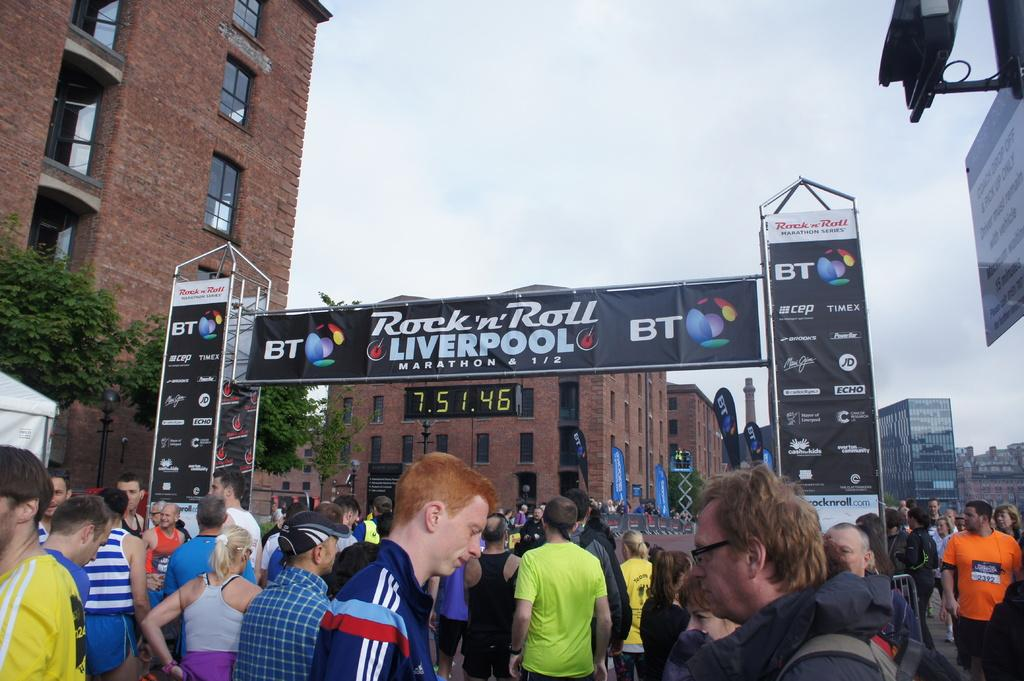<image>
Create a compact narrative representing the image presented. A crowd of people have gathered to compete in the Rock and Roll Liverpool Marathon sponsored by BT. 